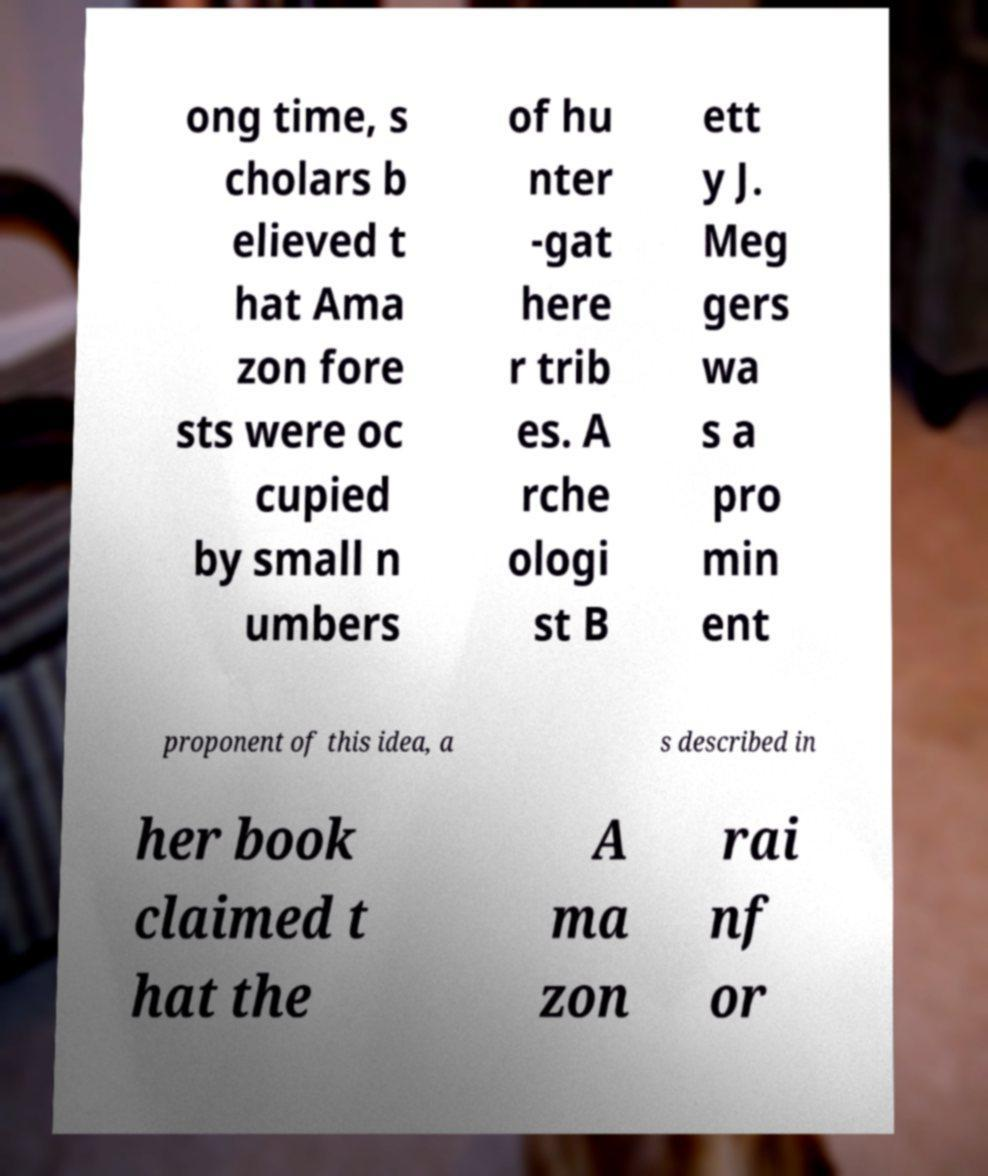I need the written content from this picture converted into text. Can you do that? ong time, s cholars b elieved t hat Ama zon fore sts were oc cupied by small n umbers of hu nter -gat here r trib es. A rche ologi st B ett y J. Meg gers wa s a pro min ent proponent of this idea, a s described in her book claimed t hat the A ma zon rai nf or 